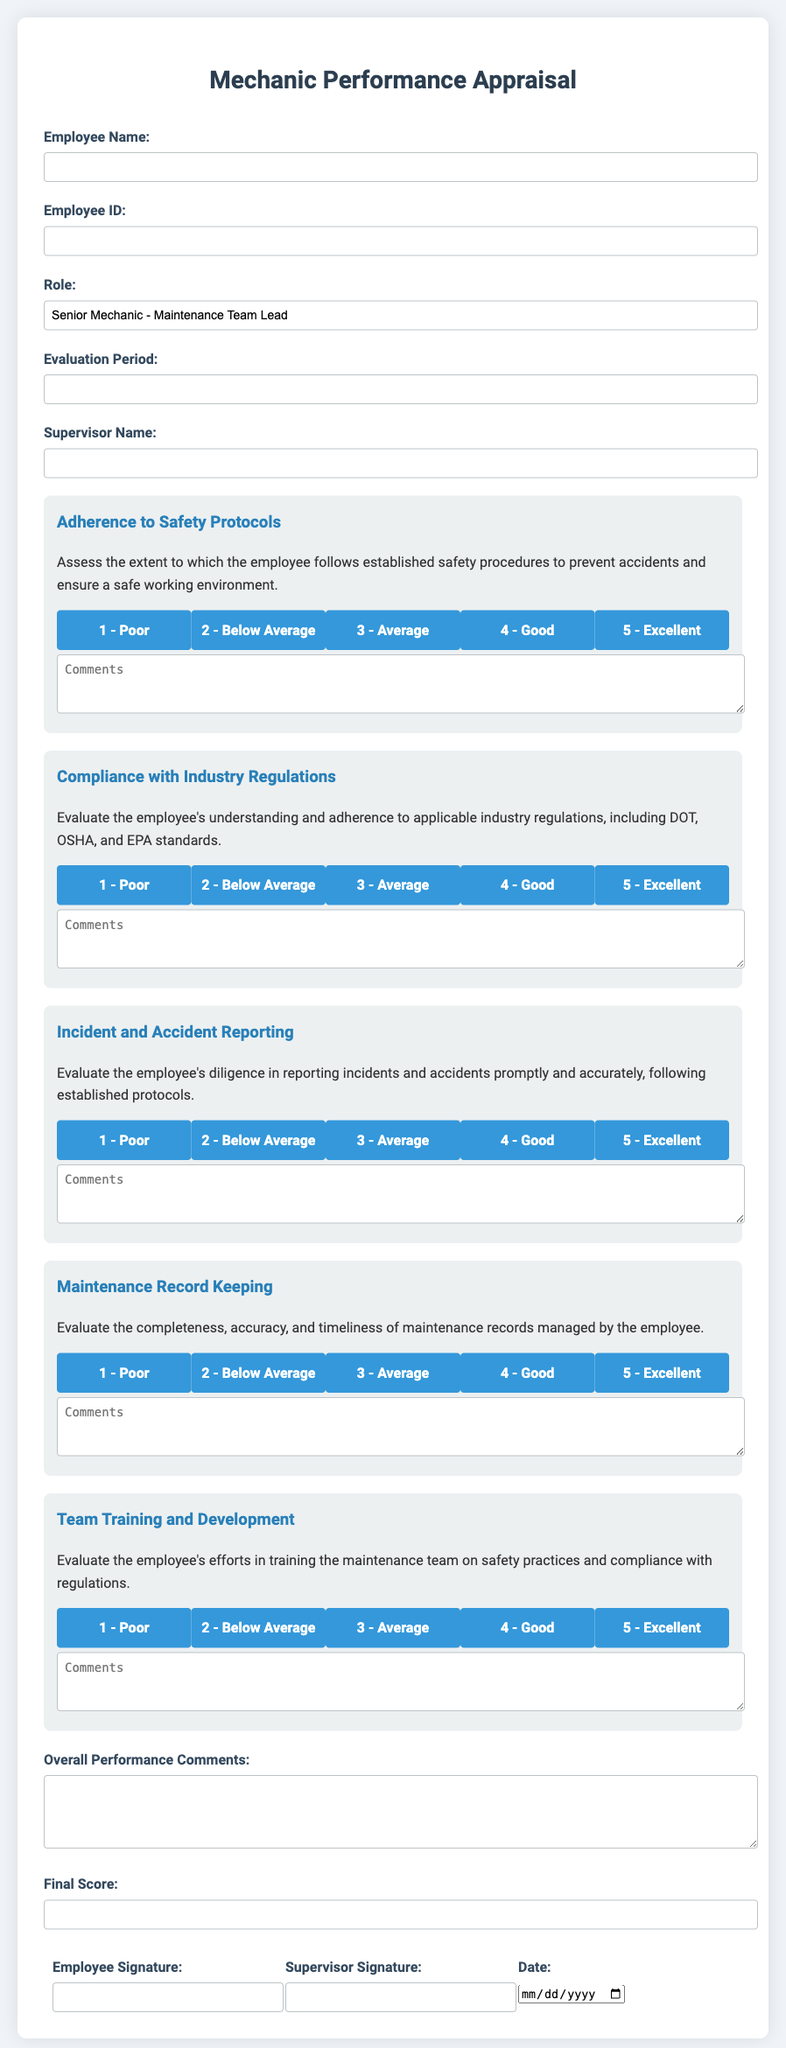What is the title of the document? The title of the document is presented at the top of the form and describes the nature of the evaluation being conducted.
Answer: Mechanic Performance Appraisal What is the role of the employee? The role is indicated in one of the form fields, specifying the position of the mechanic being evaluated.
Answer: Senior Mechanic - Maintenance Team Lead How many criteria are there for safety and compliance assessment? The document lists several criteria, each with its own evaluation section for assessment.
Answer: 5 What is one of the areas evaluated regarding compliance? The specific area mentioned in the evaluation is related to regulations that the employee must adhere to.
Answer: Compliance with Industry Regulations What should the employee provide in the comments section? The comments section is meant for additional insights regarding the evaluation for each criterion.
Answer: Comments What signature is required from the employee? The form includes a section requiring the employee's confirmation through their signing.
Answer: Employee Signature What is the date input field for? The date input field is used for recording the date of the appraisal form's completion.
Answer: Date What type of performance indicator is used for adherence to safety protocols? Each criterion utilizes a rating system to guide the assessment process.
Answer: Rating system What does the evaluation ask regarding team training? The evaluation includes an inquiry related to efforts made by the employee in a specific area.
Answer: Training the maintenance team on safety practices 